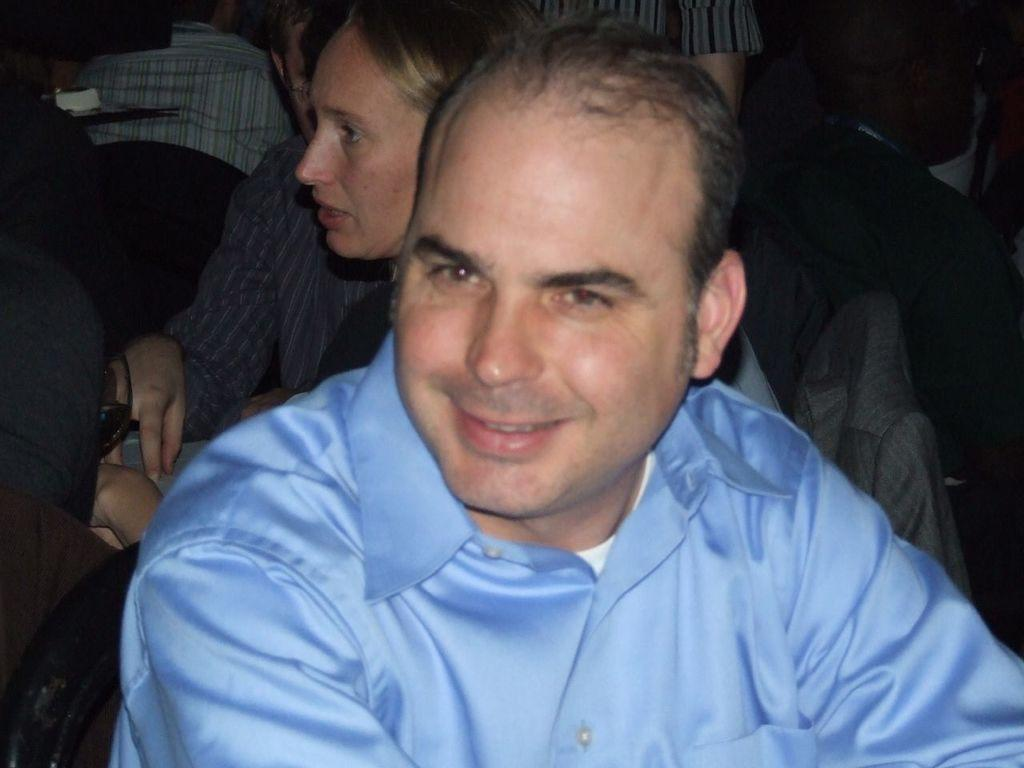What is the main subject in the foreground of the image? There is a person sitting in the foreground of the image. What is the person wearing in the image? The person is wearing a blue shirt. Can you describe the background of the image? There are people in the background of the image. What type of jar is the person holding in the image? There is no jar present in the image; the person is sitting and wearing a blue shirt. 